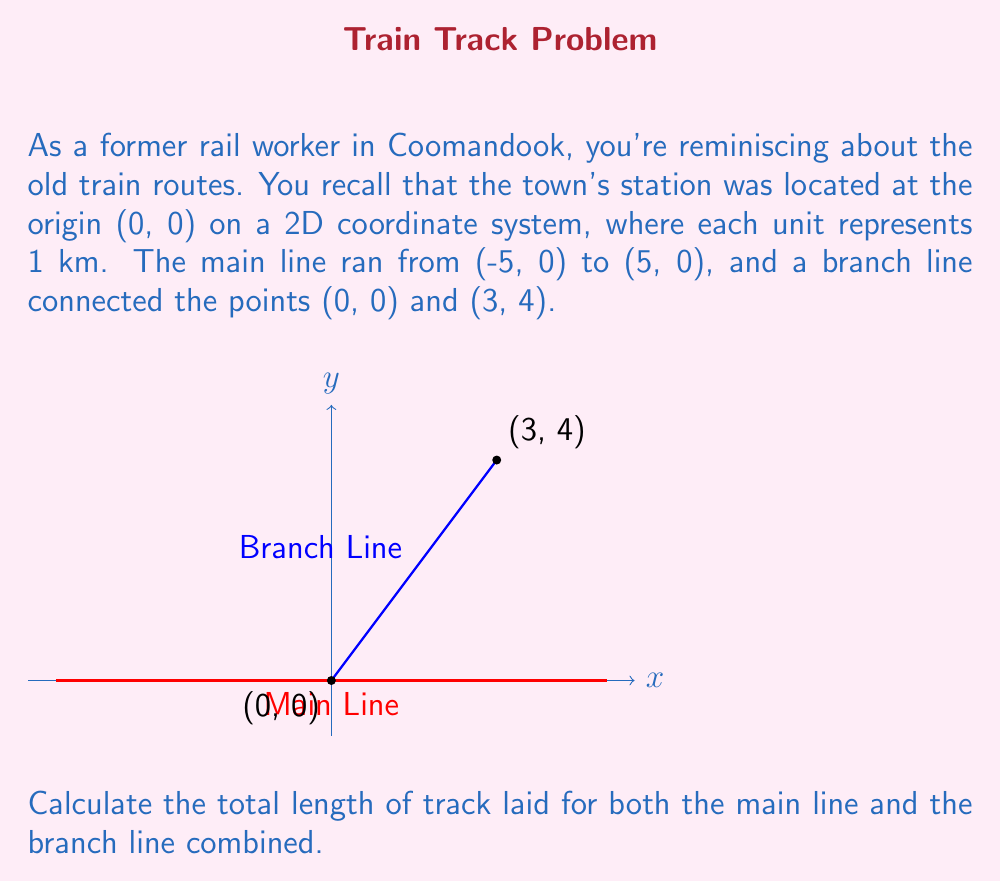Could you help me with this problem? Let's approach this step-by-step:

1) For the main line:
   - It runs from (-5, 0) to (5, 0)
   - The length is the absolute difference between x-coordinates: $|5 - (-5)| = 10$ km

2) For the branch line:
   - It runs from (0, 0) to (3, 4)
   - We can use the distance formula: $d = \sqrt{(x_2-x_1)^2 + (y_2-y_1)^2}$
   - Plugging in the coordinates:
     $$d = \sqrt{(3-0)^2 + (4-0)^2} = \sqrt{3^2 + 4^2} = \sqrt{9 + 16} = \sqrt{25} = 5$$ km

3) Total length:
   - Sum the lengths of both lines: $10 + 5 = 15$ km

Therefore, the total length of track laid is 15 km.
Answer: 15 km 